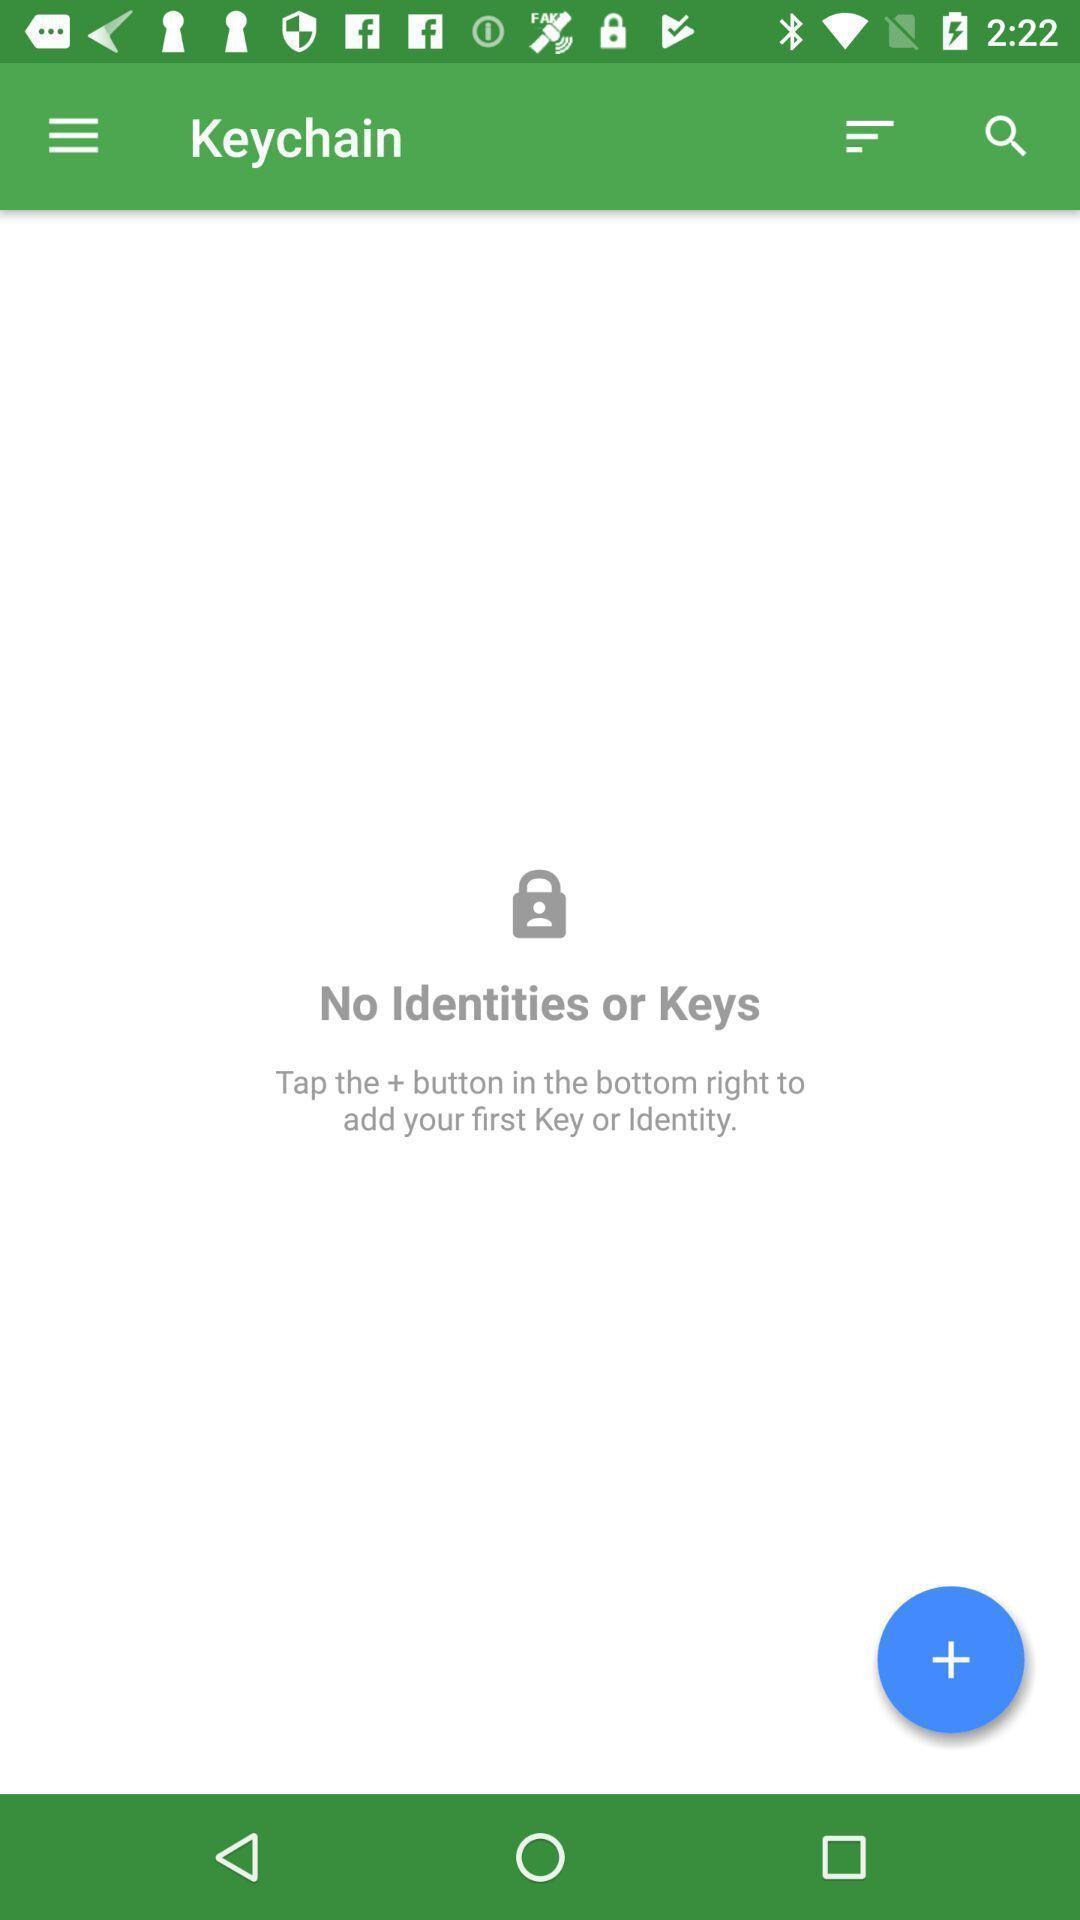Describe the content in this image. Page showing add symbol. 